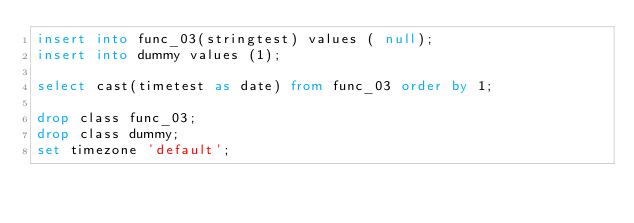Convert code to text. <code><loc_0><loc_0><loc_500><loc_500><_SQL_>insert into func_03(stringtest) values ( null);
insert into dummy values (1);

select cast(timetest as date) from func_03 order by 1;

drop class func_03;
drop class dummy;
set timezone 'default';
</code> 